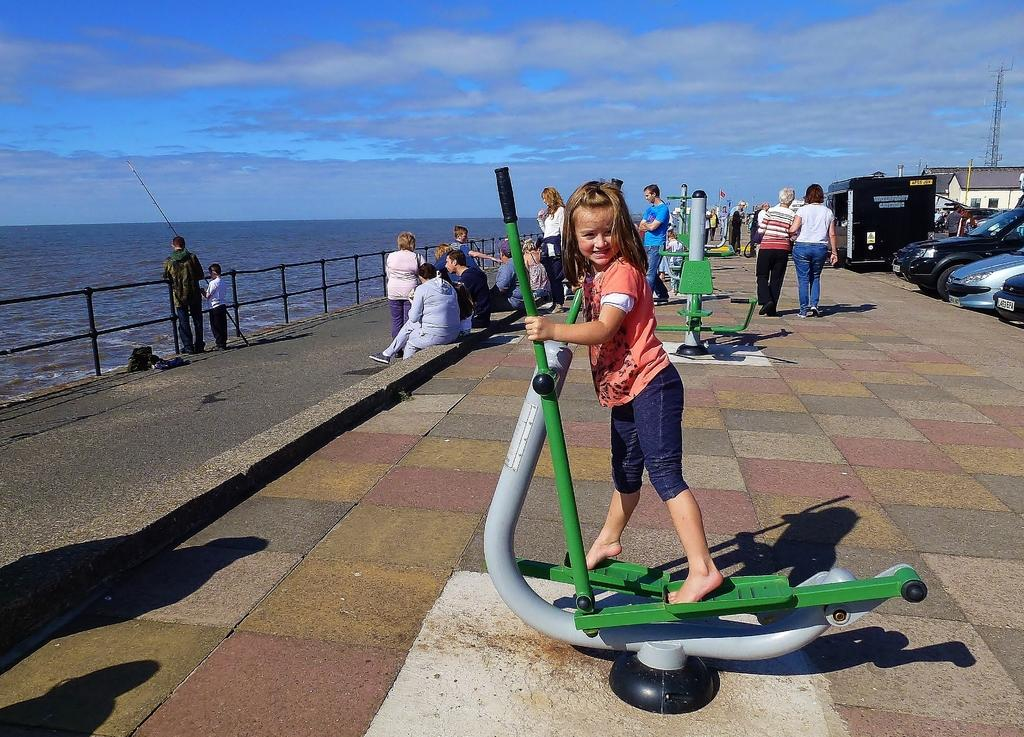What is the main subject of the image? There is a girl standing in the image. Are there any other people in the image? Yes, there are other people behind the girl. What can be seen on the left side of the image? There is fencing and water on the left side of the image. What is visible on the right side of the image? There are cars and buildings on the right side of the image. What type of sink can be seen in the image? There is no sink present in the image. How many noses can be counted on the girl in the image? It is not appropriate to count noses, but the girl has one nose, as do all humans. 